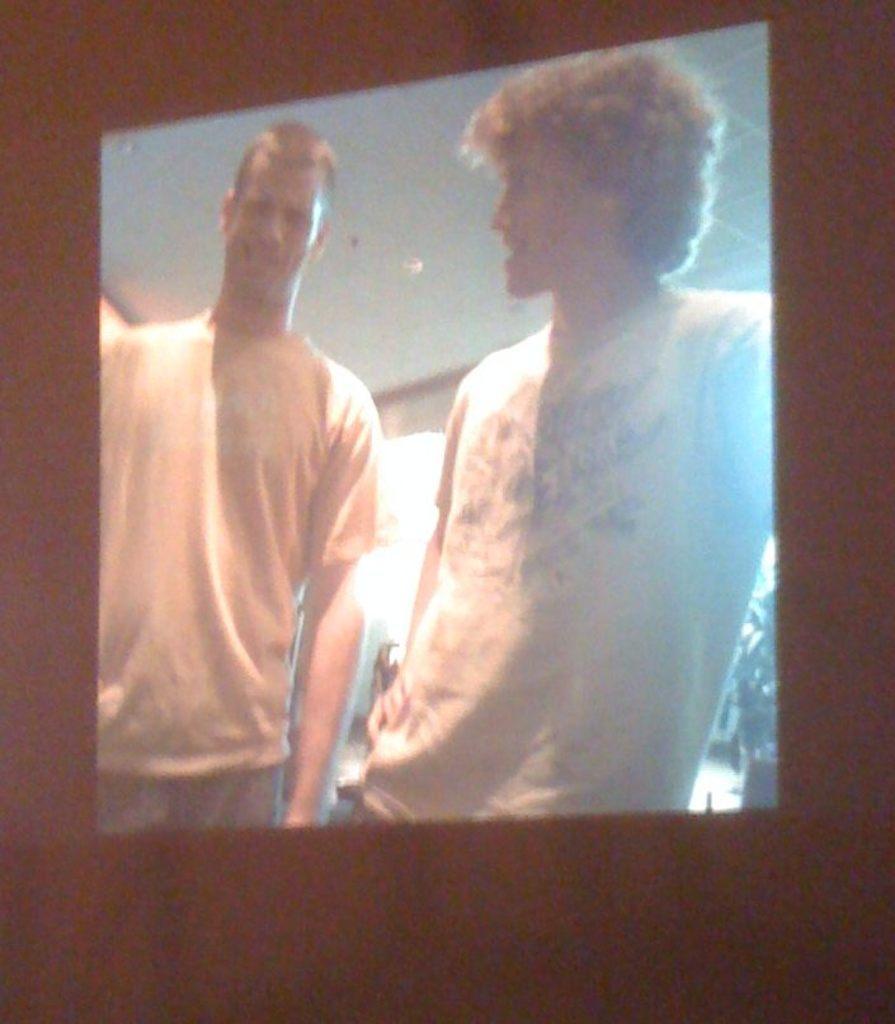Please provide a concise description of this image. In this picture, we see two men are standing. Both of them are talking to each other and they are smiling. On the right side, we see a flower pot. At the top, we see the ceiling of the room. In the background, it is black in color. This might be the television screen which is displaying the movie. 